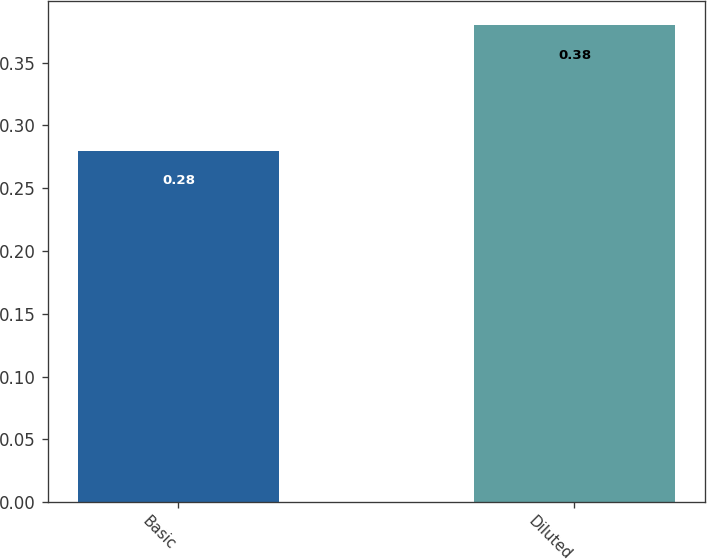Convert chart to OTSL. <chart><loc_0><loc_0><loc_500><loc_500><bar_chart><fcel>Basic<fcel>Diluted<nl><fcel>0.28<fcel>0.38<nl></chart> 